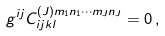Convert formula to latex. <formula><loc_0><loc_0><loc_500><loc_500>g ^ { i j } C ^ { ( J ) m _ { 1 } n _ { 1 } \cdots m _ { J } n _ { J } } _ { i j k l } = 0 \, ,</formula> 